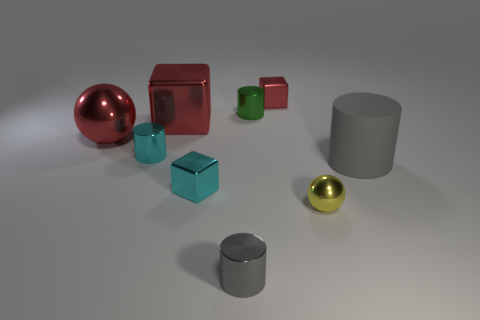How many things are big metal spheres or tiny green metal objects?
Keep it short and to the point. 2. What shape is the object that is both on the right side of the small red thing and in front of the big gray cylinder?
Ensure brevity in your answer.  Sphere. Does the green shiny thing have the same shape as the big metallic thing that is behind the red metallic sphere?
Offer a very short reply. No. Are there any gray rubber cylinders left of the yellow metal object?
Keep it short and to the point. No. There is a small cube that is the same color as the large shiny sphere; what is it made of?
Your answer should be very brief. Metal. How many blocks are large red metallic objects or matte objects?
Keep it short and to the point. 1. Is the shape of the large gray object the same as the small gray object?
Your answer should be very brief. Yes. There is a shiny sphere that is on the left side of the tiny yellow metallic object; what size is it?
Provide a succinct answer. Large. Is there a big rubber cylinder of the same color as the large metal sphere?
Keep it short and to the point. No. Does the shiny sphere left of the yellow metal thing have the same size as the tiny gray metal thing?
Offer a terse response. No. 